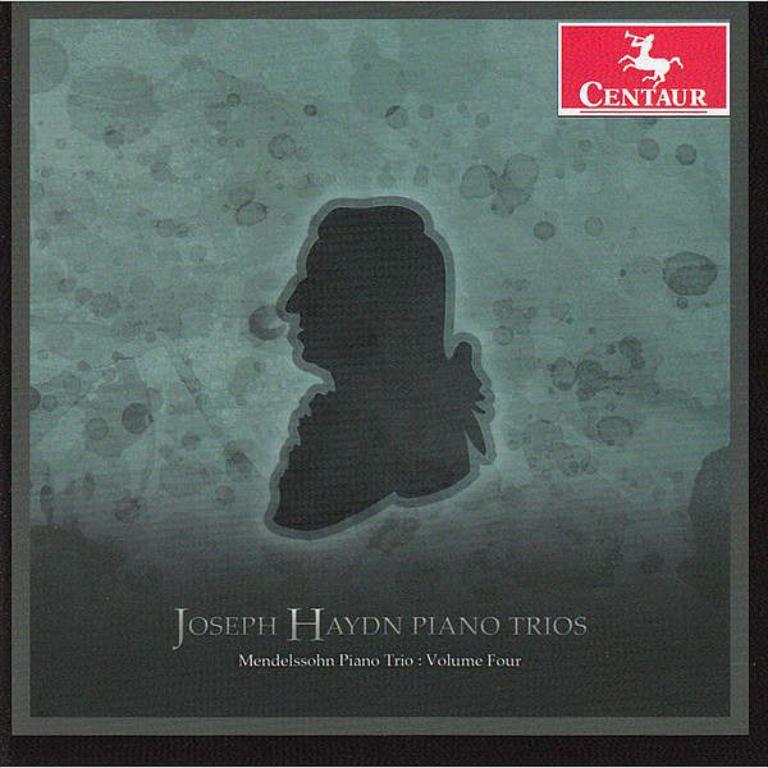What is this ad promoting?
Your answer should be compact. Joseph haydn piano trios. What volume is this album?
Make the answer very short. Four. 